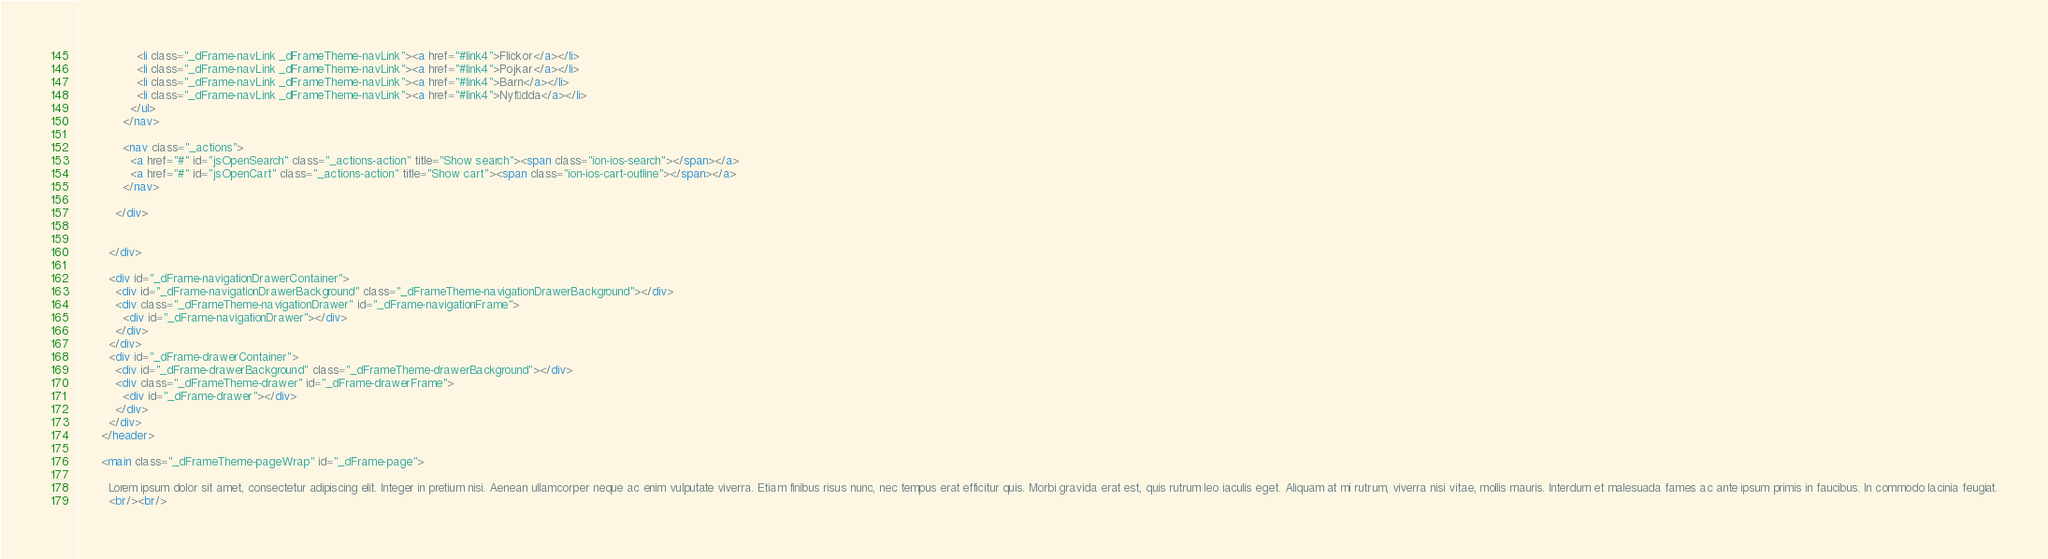<code> <loc_0><loc_0><loc_500><loc_500><_HTML_>                <li class="_dFrame-navLink _dFrameTheme-navLink"><a href="#link4">Flickor</a></li>
                <li class="_dFrame-navLink _dFrameTheme-navLink"><a href="#link4">Pojkar</a></li>
                <li class="_dFrame-navLink _dFrameTheme-navLink"><a href="#link4">Barn</a></li>
                <li class="_dFrame-navLink _dFrameTheme-navLink"><a href="#link4">Nyfödda</a></li>
              </ul>
            </nav>

            <nav class="_actions">
              <a href="#" id="jsOpenSearch" class="_actions-action" title="Show search"><span class="ion-ios-search"></span></a>
              <a href="#" id="jsOpenCart" class="_actions-action" title="Show cart"><span class="ion-ios-cart-outline"></span></a>
            </nav>

          </div>
          
          
        </div>

        <div id="_dFrame-navigationDrawerContainer">
          <div id="_dFrame-navigationDrawerBackground" class="_dFrameTheme-navigationDrawerBackground"></div>
          <div class="_dFrameTheme-navigationDrawer" id="_dFrame-navigationFrame">
            <div id="_dFrame-navigationDrawer"></div>
          </div>
        </div>
        <div id="_dFrame-drawerContainer">
          <div id="_dFrame-drawerBackground" class="_dFrameTheme-drawerBackground"></div>
          <div class="_dFrameTheme-drawer" id="_dFrame-drawerFrame">
            <div id="_dFrame-drawer"></div>
          </div>
        </div>
      </header>
      
      <main class="_dFrameTheme-pageWrap" id="_dFrame-page">
        
        Lorem ipsum dolor sit amet, consectetur adipiscing elit. Integer in pretium nisi. Aenean ullamcorper neque ac enim vulputate viverra. Etiam finibus risus nunc, nec tempus erat efficitur quis. Morbi gravida erat est, quis rutrum leo iaculis eget. Aliquam at mi rutrum, viverra nisi vitae, mollis mauris. Interdum et malesuada fames ac ante ipsum primis in faucibus. In commodo lacinia feugiat.
        <br/><br/></code> 